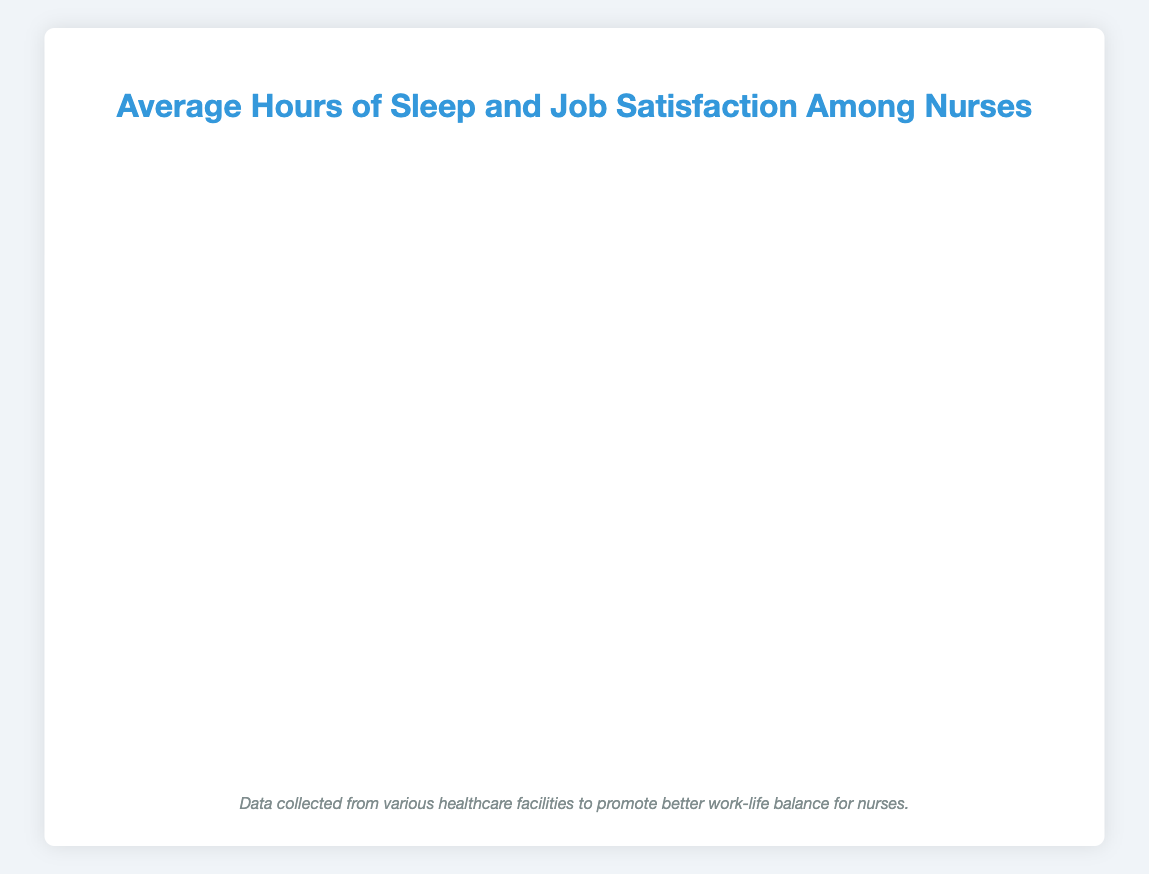What percentage of nurses at Lakeside Hospital experience very high job satisfaction with 8+ hours of sleep? Look at the bar segment corresponding to 8+ hours of sleep for Lakeside Hospital. It shows a percentage of 95.
Answer: 95% How does the job satisfaction for nurses with 6-8 hours of sleep compare between City Hospital and Sunrise Health Center? Compare the bar segments for 6-8 hours of sleep for both facilities. City Hospital's bar is longer, indicating a percentage of 70%, while Sunrise Health Center's bar is shorter, indicating a percentage of 60%.
Answer: City Hospital has higher satisfaction Which facility reports the lowest level of satisfaction for nurses who get 0-4 hours of sleep? Compare the bar segments for 0-4 hours of sleep across all facilities. The shortest bar belongs to Lakeside Hospital, showing a percentage of 20%.
Answer: Lakeside Hospital What is the average job satisfaction percentage for nurses with 4-6 hours of sleep across all facilities? Add the percentages for 4-6 hours of sleep from all facilities and divide by the number of facilities: (50 + 55 + 45 + 50 + 60) / 5 = 52.
Answer: 52% Which facility has the highest percentage of very high job satisfaction for nurses with 8+ hours of sleep? Look at the bar segments for 8+ hours of sleep for all facilities. The longest bar is for Lakeside Hospital, showing a percentage of 95%.
Answer: Lakeside Hospital How much higher is the percentage of nurses with very high satisfaction at Westside Medical Center for 8+ hours of sleep compared to 0-4 hours of sleep? Subtract the percentage for 0-4 hours from the percentage for 8+ hours at Westside Medical Center: 88% - 40% = 48%.
Answer: 48% What trend do you observe in job satisfaction as the hours of sleep increase across all facilities? Generally, the bars for job satisfaction increase in length as sleep hours increase, indicating higher satisfaction levels with more sleep hours.
Answer: Higher satisfaction with more sleep How does the job satisfaction of Green Valley Clinic nurses with 6-8 hours of sleep compare to those at Westside Medical Center? Compare the bar segments for 6-8 hours of sleep. Green Valley Clinic has a percentage of 65%, and Westside Medical Center has a percentage of 72%.
Answer: Westside Medical Center has higher satisfaction What common patterns do you see in the relationship between sleep duration and job satisfaction across all facilities? Generally, each facility shows increasing percentages of job satisfaction as sleep duration increases. This pattern suggests a positive correlation between more sleep and higher job satisfaction.
Answer: Positive correlation between sleep and satisfaction Which facility shows the smallest difference in job satisfaction percentages between the 4-6 hours and 8+ hours sleep ranges? Calculate the difference for each facility: 
City Hospital: 90% - 50% = 40%
Green Valley Clinic: 85% - 55% = 30%
Sunrise Health Center: 80% - 45% = 35%
Lakeside Hospital: 95% - 50% = 45%
Westside Medical Center: 88% - 60% = 28%
The smallest difference is 28% at Westside Medical Center.
Answer: Westside Medical Center 